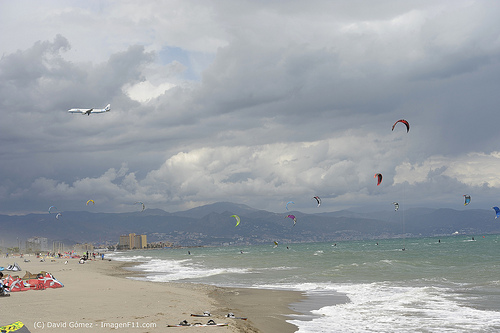If this beach were to host an international kite festival, describe a significant event that could take place. At the international kite festival, the grand event would be the ‘Kite Symphony Show.’ In this spectacular show, kites of various shapes, sizes, and colors would mimic an orchestra in the sky. As the music begins, giant dragon kites would soar majestically, followed by butterfly kites performing delicate ballet-like movements. The show stopper would be an enormous kite resembling a spaceship, which would launch fireworks and create a dazzling display of light and color, synchronized with the beats of the symphony. The festival would conclude with a communal release of hundreds of kites into the sky, symbolizing freedom and unity. 